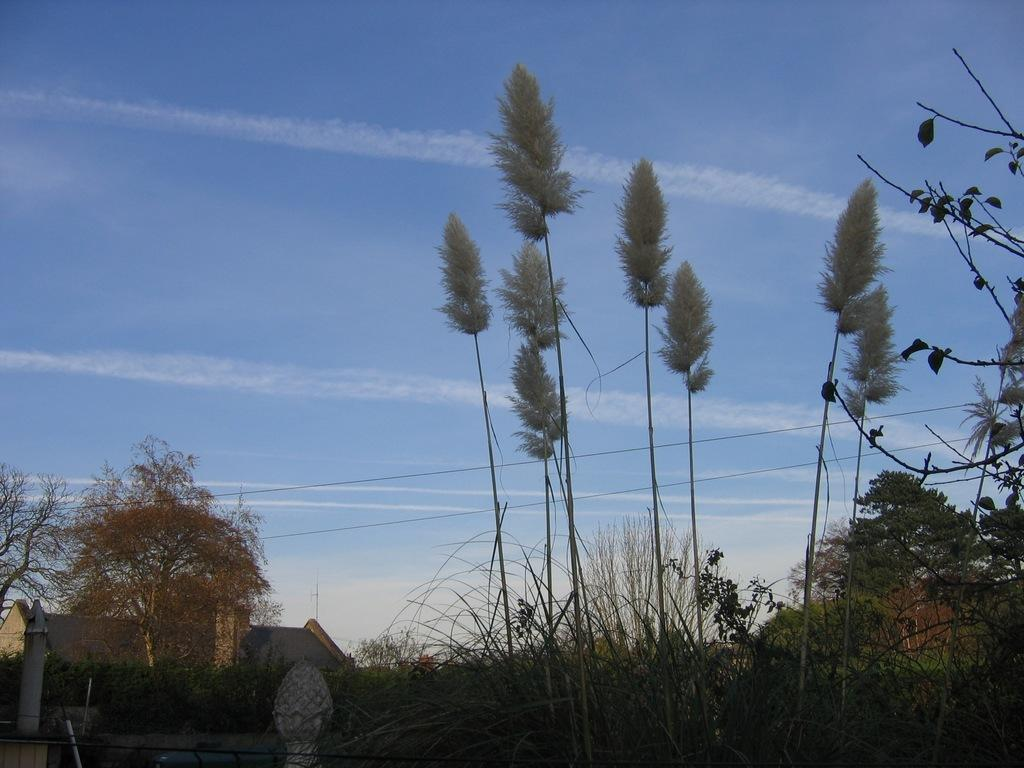What type of vegetation can be seen in the image? There are plants and trees in the image. What structure is located on the left side of the image? There appears to be a house on the left side of the image. What is visible in the background of the image? The sky is visible in the background of the image. How does the feeling of the plants and trees change throughout the day in the image? The image does not convey any feelings of the plants and trees, nor does it depict a time-lapse of the day. --- Facts: 1. There is a person sitting on a chair in the image. 2. The person is holding a book. 3. There is a table next to the chair. 4. The table has a lamp on it. 5. The background of the image is a room. Absurd Topics: dance, ocean, parrot Conversation: What is the person in the image doing? The person is sitting on a chair in the image. What object is the person holding? The person is holding a book. What is located next to the chair? There is a table next to the chair. What is on the table? The table has a lamp on it. What is the setting of the image? The background of the image is a room. Reasoning: Let's think step by step in order to produce the conversation. We start by identifying the main subject in the image, which is the person sitting on a chair. Then, we expand the conversation to include other items that are also visible, such as the book, table, lamp, and the room setting. Each question is designed to elicit a specific detail about the image that is known from the provided facts. Absurd Question/Answer: Can you see any parrots flying over the ocean in the image? There is no ocean or parrots present in the image; it depicts a person sitting in a room with a book and a table with a lamp. 